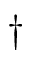<formula> <loc_0><loc_0><loc_500><loc_500>\dag</formula> 